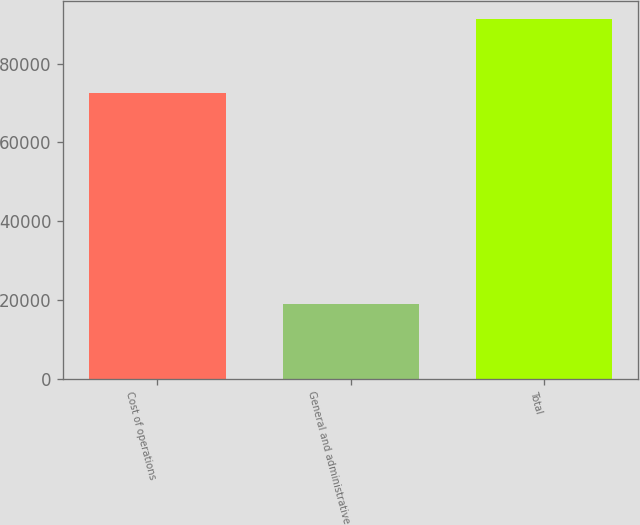Convert chart to OTSL. <chart><loc_0><loc_0><loc_500><loc_500><bar_chart><fcel>Cost of operations<fcel>General and administrative<fcel>Total<nl><fcel>72569<fcel>18812<fcel>91381<nl></chart> 